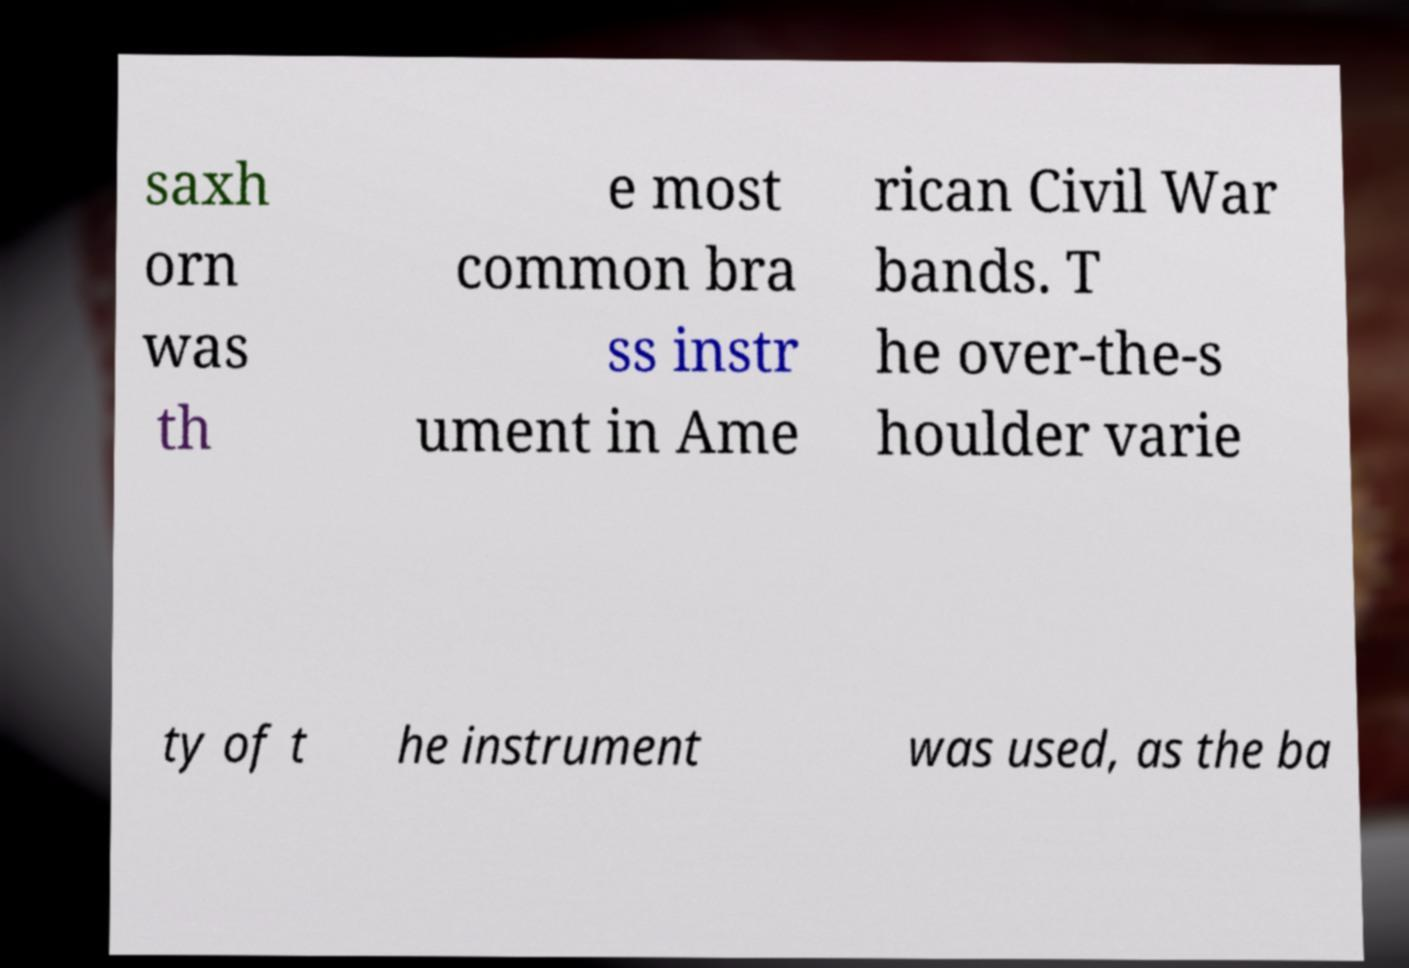Please identify and transcribe the text found in this image. saxh orn was th e most common bra ss instr ument in Ame rican Civil War bands. T he over-the-s houlder varie ty of t he instrument was used, as the ba 